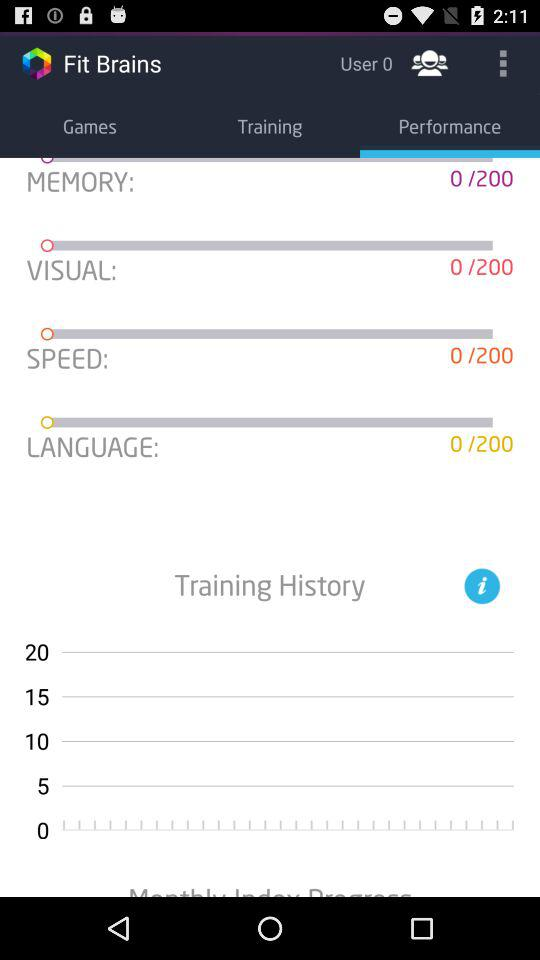How many different categories are there?
Answer the question using a single word or phrase. 4 